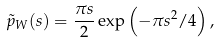<formula> <loc_0><loc_0><loc_500><loc_500>\tilde { p } _ { W } ( s ) = \frac { \pi s } { 2 } \exp { \left ( - \pi s ^ { 2 } / 4 \right ) } \, ,</formula> 